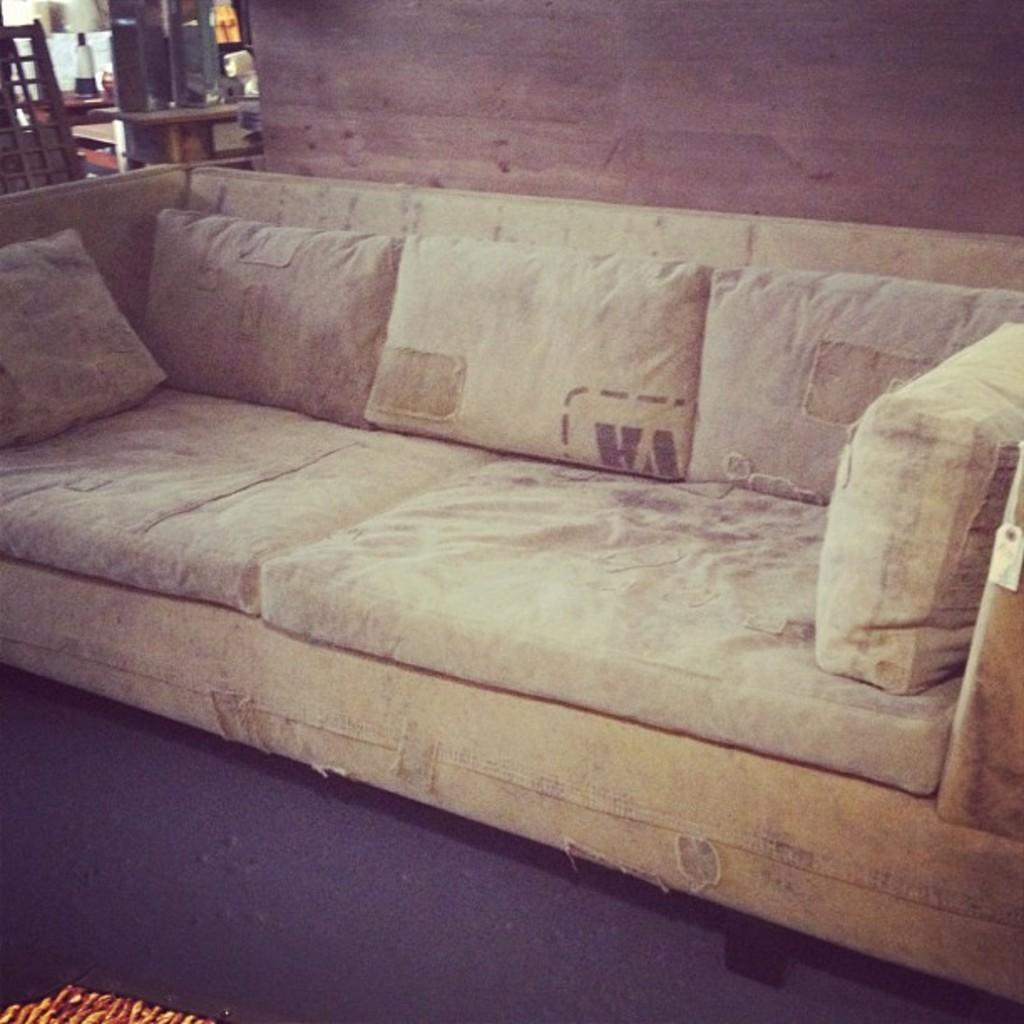What type of furniture is present in the room? There is a sofa and a table in the room. What is on the table in the room? There is a bottle on the table, along with additional objects. What type of sea creature can be seen swimming near the heart on the table? There is no sea creature or heart present on the table in the image. 